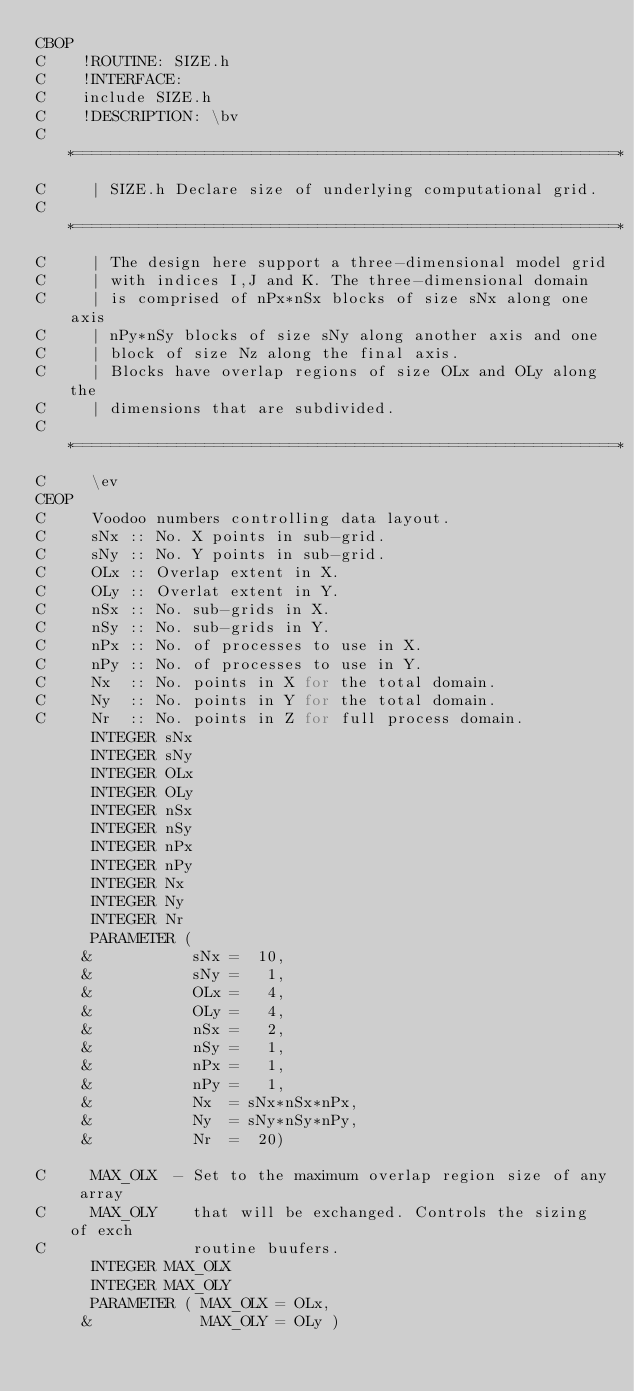Convert code to text. <code><loc_0><loc_0><loc_500><loc_500><_C_>CBOP
C    !ROUTINE: SIZE.h
C    !INTERFACE:
C    include SIZE.h
C    !DESCRIPTION: \bv
C     *==========================================================*
C     | SIZE.h Declare size of underlying computational grid.     
C     *==========================================================*
C     | The design here support a three-dimensional model grid    
C     | with indices I,J and K. The three-dimensional domain      
C     | is comprised of nPx*nSx blocks of size sNx along one axis 
C     | nPy*nSy blocks of size sNy along another axis and one     
C     | block of size Nz along the final axis.                    
C     | Blocks have overlap regions of size OLx and OLy along the 
C     | dimensions that are subdivided.                           
C     *==========================================================*
C     \ev
CEOP
C     Voodoo numbers controlling data layout.
C     sNx :: No. X points in sub-grid.
C     sNy :: No. Y points in sub-grid.
C     OLx :: Overlap extent in X.
C     OLy :: Overlat extent in Y.
C     nSx :: No. sub-grids in X.
C     nSy :: No. sub-grids in Y.
C     nPx :: No. of processes to use in X.
C     nPy :: No. of processes to use in Y.
C     Nx  :: No. points in X for the total domain.
C     Ny  :: No. points in Y for the total domain.
C     Nr  :: No. points in Z for full process domain.
      INTEGER sNx
      INTEGER sNy
      INTEGER OLx
      INTEGER OLy
      INTEGER nSx
      INTEGER nSy
      INTEGER nPx
      INTEGER nPy
      INTEGER Nx
      INTEGER Ny
      INTEGER Nr
      PARAMETER (
     &           sNx =  10,
     &           sNy =   1,
     &           OLx =   4,
     &           OLy =   4,
     &           nSx =   2,
     &           nSy =   1,
     &           nPx =   1,
     &           nPy =   1,
     &           Nx  = sNx*nSx*nPx,
     &           Ny  = sNy*nSy*nPy,
     &           Nr  =  20)

C     MAX_OLX  - Set to the maximum overlap region size of any array
C     MAX_OLY    that will be exchanged. Controls the sizing of exch
C                routine buufers.
      INTEGER MAX_OLX
      INTEGER MAX_OLY
      PARAMETER ( MAX_OLX = OLx,
     &            MAX_OLY = OLy )

</code> 